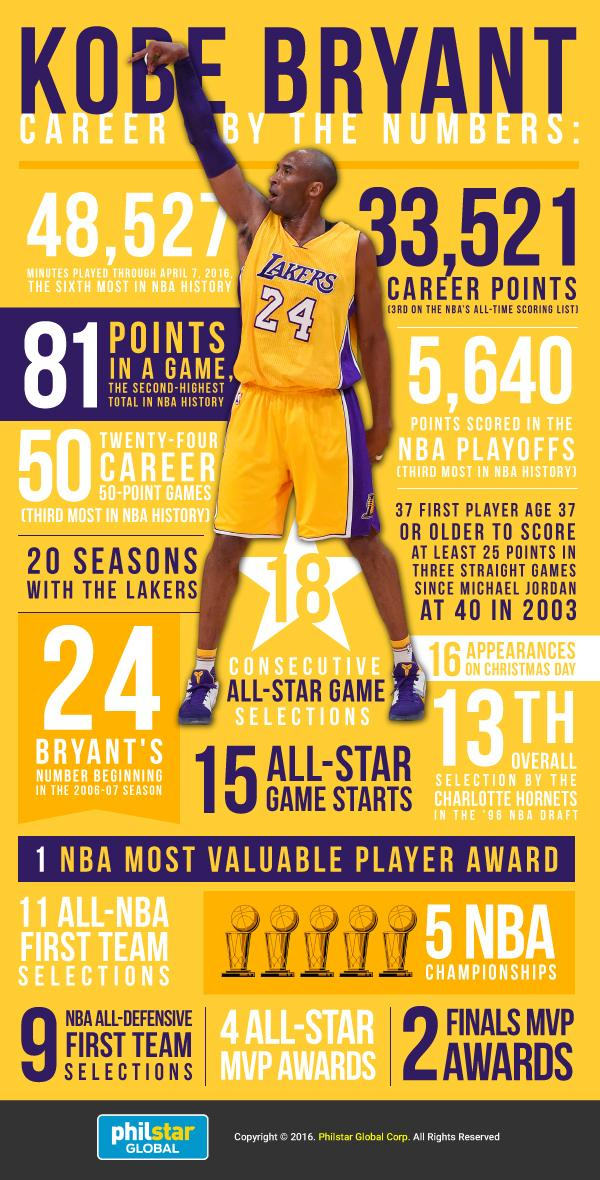Specify some key components in this picture. Kobe Bryant is a member of the Los Angeles Lakers. From April 7, 2016, a total of 48,527 minutes had been played. During the NBA playoffs, a total of 5,640 points were scored. Five trophies have been displayed. The number on the T-shirt is 24. 